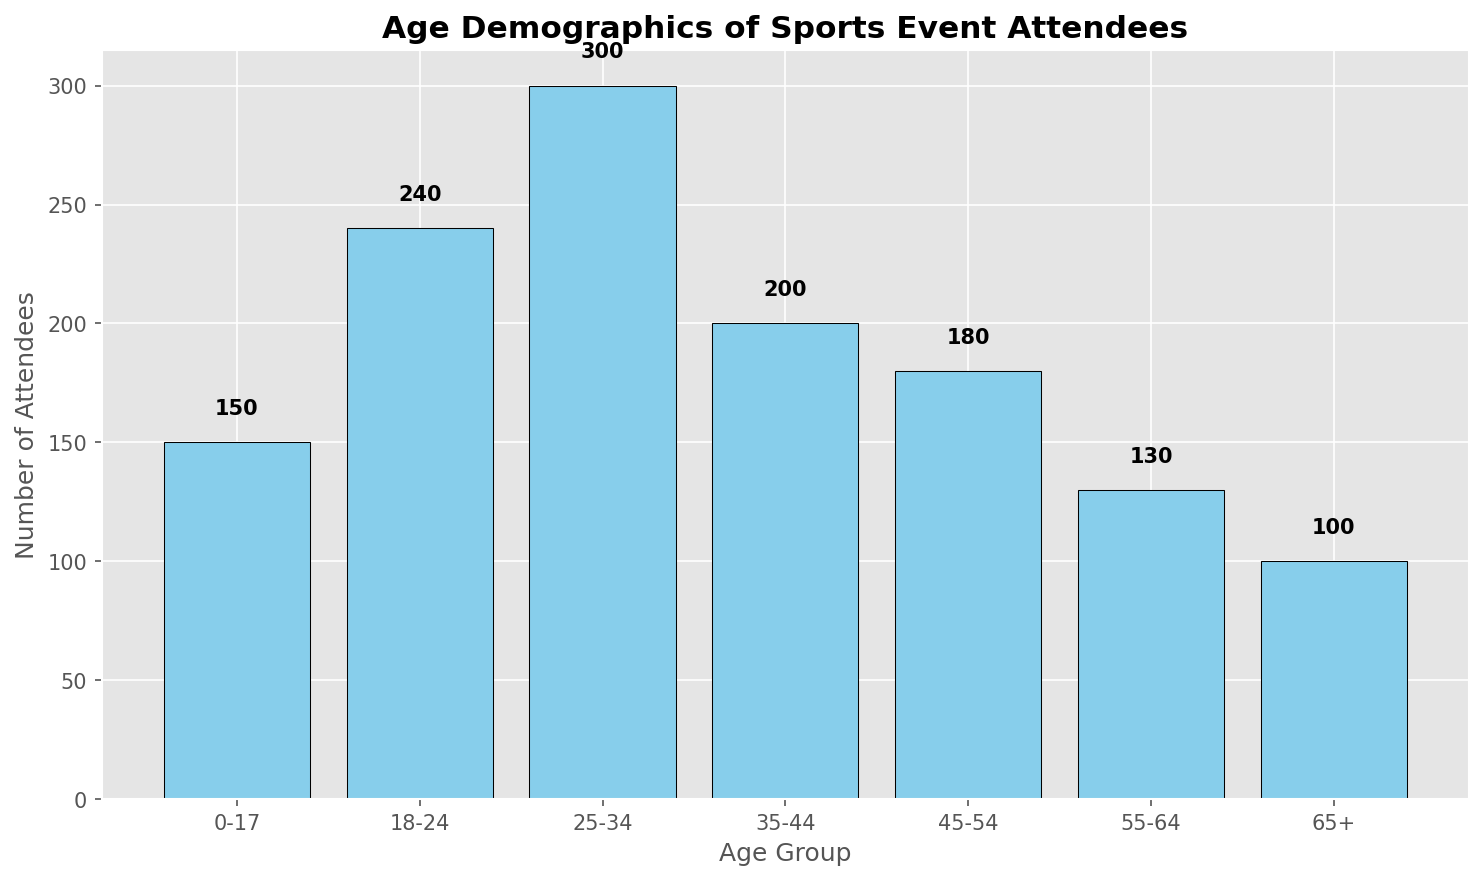What's the total number of attendees in the age groups 25-34 and 35-44? The figure shows 300 attendees in the 25-34 age group and 200 in the 35-44 age group. Adding these together gives 300 + 200 = 500.
Answer: 500 Which age group has the highest number of attendees? The figure indicates that the 25-34 age group has the tallest bar, representing 300 attendees, which is more than any other age group.
Answer: 25-34 How does the number of attendees in the 18-24 age group compare to those in the 45-54 age group? The figure shows that the 18-24 age group has 240 attendees, while the 45-54 age group has 180 attendees. Therefore, the 18-24 age group has 60 more attendees than the 45-54 age group.
Answer: 18-24 has 60 more attendees What is the average number of attendees across all age groups? Summing the number of attendees and dividing by the number of age groups: (150 + 240 + 300 + 200 + 180 + 130 + 100) / 7 = 1300 / 7 ≈ 185.71.
Answer: 185.71 Are there more attendees in the combined 0-17 and 65+ age groups than in the 18-24 age group? The 0-17 age group has 150 attendees and the 65+ age group has 100 attendees. Adding these together, 150 + 100 = 250, which is more than the 240 attendees in the 18-24 age group.
Answer: Yes Which age group has the fewest attendees? The shortest bar in the figure represents the 65+ age group with 100 attendees, which is fewer than any other age group.
Answer: 65+ What’s the difference in the number of attendees between the 25-34 and 55-64 age groups? The 25-34 age group has 300 attendees and the 55-64 age group has 130 attendees. The difference is 300 - 130 = 170.
Answer: 170 What proportion of the total attendees are in the 35-44 age group? The total number of attendees is 1300. The 35-44 age group has 200 attendees. The proportion is 200 / 1300 = 0.1538, or about 15.38%.
Answer: 15.38% Between which consecutive age groups is there the largest decrease in the number of attendees? The largest decrease appears between 25-34 (300 attendees) and 35-44 (200 attendees), a drop of 100 attendees.
Answer: Between 25-34 and 35-44 